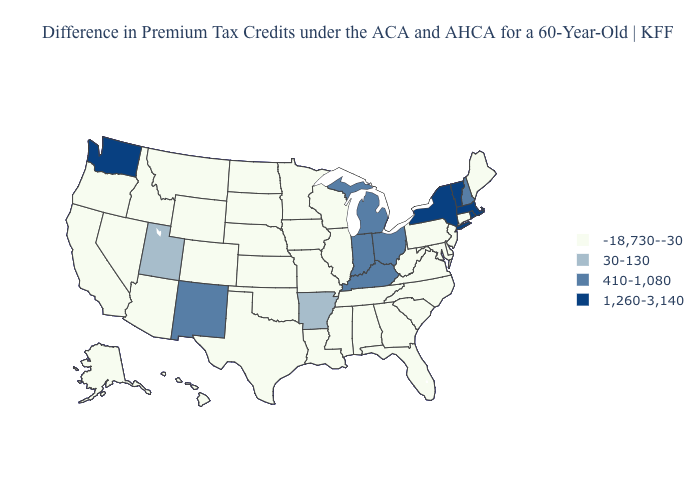Does Maine have the lowest value in the Northeast?
Keep it brief. Yes. Name the states that have a value in the range 410-1,080?
Short answer required. Indiana, Kentucky, Michigan, New Hampshire, New Mexico, Ohio. Name the states that have a value in the range 410-1,080?
Write a very short answer. Indiana, Kentucky, Michigan, New Hampshire, New Mexico, Ohio. What is the lowest value in the USA?
Give a very brief answer. -18,730--30. Name the states that have a value in the range -18,730--30?
Concise answer only. Alabama, Alaska, Arizona, California, Colorado, Connecticut, Delaware, Florida, Georgia, Hawaii, Idaho, Illinois, Iowa, Kansas, Louisiana, Maine, Maryland, Minnesota, Mississippi, Missouri, Montana, Nebraska, Nevada, New Jersey, North Carolina, North Dakota, Oklahoma, Oregon, Pennsylvania, South Carolina, South Dakota, Tennessee, Texas, Virginia, West Virginia, Wisconsin, Wyoming. Name the states that have a value in the range 410-1,080?
Give a very brief answer. Indiana, Kentucky, Michigan, New Hampshire, New Mexico, Ohio. What is the highest value in states that border Vermont?
Concise answer only. 1,260-3,140. Name the states that have a value in the range 410-1,080?
Write a very short answer. Indiana, Kentucky, Michigan, New Hampshire, New Mexico, Ohio. What is the highest value in the USA?
Short answer required. 1,260-3,140. Name the states that have a value in the range -18,730--30?
Write a very short answer. Alabama, Alaska, Arizona, California, Colorado, Connecticut, Delaware, Florida, Georgia, Hawaii, Idaho, Illinois, Iowa, Kansas, Louisiana, Maine, Maryland, Minnesota, Mississippi, Missouri, Montana, Nebraska, Nevada, New Jersey, North Carolina, North Dakota, Oklahoma, Oregon, Pennsylvania, South Carolina, South Dakota, Tennessee, Texas, Virginia, West Virginia, Wisconsin, Wyoming. Is the legend a continuous bar?
Answer briefly. No. Among the states that border North Carolina , which have the highest value?
Write a very short answer. Georgia, South Carolina, Tennessee, Virginia. Does Kentucky have the lowest value in the South?
Answer briefly. No. Which states have the lowest value in the MidWest?
Short answer required. Illinois, Iowa, Kansas, Minnesota, Missouri, Nebraska, North Dakota, South Dakota, Wisconsin. 